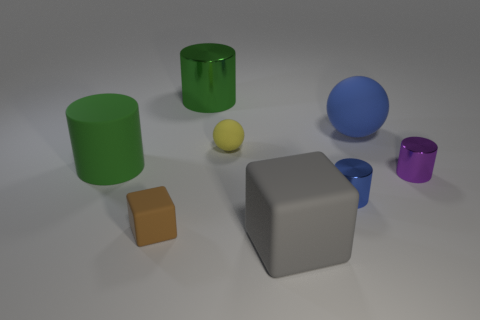Subtract all large green matte cylinders. How many cylinders are left? 3 Add 1 small rubber blocks. How many objects exist? 9 Subtract all green cylinders. How many cylinders are left? 2 Subtract all balls. How many objects are left? 6 Subtract 4 cylinders. How many cylinders are left? 0 Subtract all brown blocks. Subtract all purple balls. How many blocks are left? 1 Subtract all green cubes. How many green cylinders are left? 2 Subtract all green cylinders. Subtract all big gray balls. How many objects are left? 6 Add 1 yellow rubber objects. How many yellow rubber objects are left? 2 Add 5 yellow objects. How many yellow objects exist? 6 